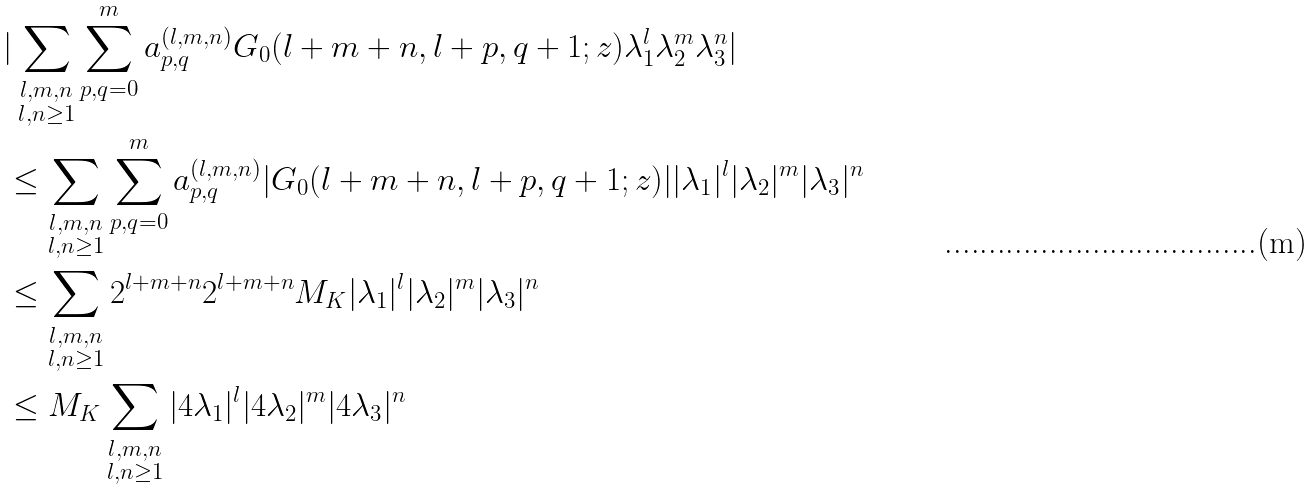Convert formula to latex. <formula><loc_0><loc_0><loc_500><loc_500>& | \sum _ { \substack { l , m , n \\ l , n \geq 1 } } \sum _ { p , q = 0 } ^ { m } a _ { p , q } ^ { ( l , m , n ) } G _ { 0 } ( l + m + n , l + p , q + 1 ; z ) \lambda _ { 1 } ^ { l } \lambda _ { 2 } ^ { m } \lambda _ { 3 } ^ { n } | \\ & \leq \sum _ { \substack { l , m , n \\ l , n \geq 1 } } \sum _ { p , q = 0 } ^ { m } a _ { p , q } ^ { ( l , m , n ) } | G _ { 0 } ( l + m + n , l + p , q + 1 ; z ) | | \lambda _ { 1 } | ^ { l } | \lambda _ { 2 } | ^ { m } | \lambda _ { 3 } | ^ { n } \\ & \leq \sum _ { \substack { l , m , n \\ l , n \geq 1 } } 2 ^ { l + m + n } 2 ^ { l + m + n } M _ { K } | \lambda _ { 1 } | ^ { l } | \lambda _ { 2 } | ^ { m } | \lambda _ { 3 } | ^ { n } \\ & \leq M _ { K } \sum _ { \substack { l , m , n \\ l , n \geq 1 } } | 4 \lambda _ { 1 } | ^ { l } | 4 \lambda _ { 2 } | ^ { m } | 4 \lambda _ { 3 } | ^ { n }</formula> 